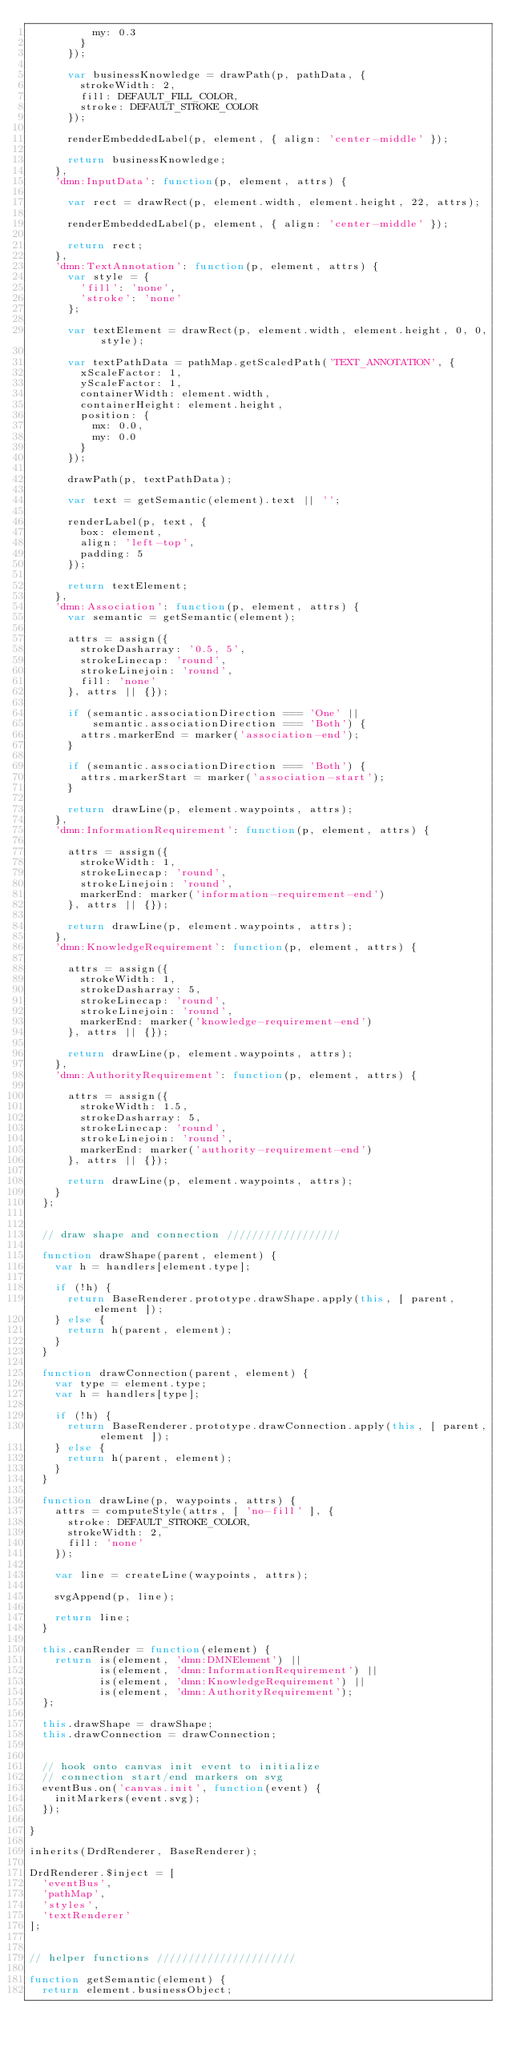Convert code to text. <code><loc_0><loc_0><loc_500><loc_500><_JavaScript_>          my: 0.3
        }
      });

      var businessKnowledge = drawPath(p, pathData, {
        strokeWidth: 2,
        fill: DEFAULT_FILL_COLOR,
        stroke: DEFAULT_STROKE_COLOR
      });

      renderEmbeddedLabel(p, element, { align: 'center-middle' });

      return businessKnowledge;
    },
    'dmn:InputData': function(p, element, attrs) {

      var rect = drawRect(p, element.width, element.height, 22, attrs);

      renderEmbeddedLabel(p, element, { align: 'center-middle' });

      return rect;
    },
    'dmn:TextAnnotation': function(p, element, attrs) {
      var style = {
        'fill': 'none',
        'stroke': 'none'
      };

      var textElement = drawRect(p, element.width, element.height, 0, 0, style);

      var textPathData = pathMap.getScaledPath('TEXT_ANNOTATION', {
        xScaleFactor: 1,
        yScaleFactor: 1,
        containerWidth: element.width,
        containerHeight: element.height,
        position: {
          mx: 0.0,
          my: 0.0
        }
      });

      drawPath(p, textPathData);

      var text = getSemantic(element).text || '';

      renderLabel(p, text, {
        box: element,
        align: 'left-top',
        padding: 5
      });

      return textElement;
    },
    'dmn:Association': function(p, element, attrs) {
      var semantic = getSemantic(element);

      attrs = assign({
        strokeDasharray: '0.5, 5',
        strokeLinecap: 'round',
        strokeLinejoin: 'round',
        fill: 'none'
      }, attrs || {});

      if (semantic.associationDirection === 'One' ||
          semantic.associationDirection === 'Both') {
        attrs.markerEnd = marker('association-end');
      }

      if (semantic.associationDirection === 'Both') {
        attrs.markerStart = marker('association-start');
      }

      return drawLine(p, element.waypoints, attrs);
    },
    'dmn:InformationRequirement': function(p, element, attrs) {

      attrs = assign({
        strokeWidth: 1,
        strokeLinecap: 'round',
        strokeLinejoin: 'round',
        markerEnd: marker('information-requirement-end')
      }, attrs || {});

      return drawLine(p, element.waypoints, attrs);
    },
    'dmn:KnowledgeRequirement': function(p, element, attrs) {

      attrs = assign({
        strokeWidth: 1,
        strokeDasharray: 5,
        strokeLinecap: 'round',
        strokeLinejoin: 'round',
        markerEnd: marker('knowledge-requirement-end')
      }, attrs || {});

      return drawLine(p, element.waypoints, attrs);
    },
    'dmn:AuthorityRequirement': function(p, element, attrs) {

      attrs = assign({
        strokeWidth: 1.5,
        strokeDasharray: 5,
        strokeLinecap: 'round',
        strokeLinejoin: 'round',
        markerEnd: marker('authority-requirement-end')
      }, attrs || {});

      return drawLine(p, element.waypoints, attrs);
    }
  };


  // draw shape and connection //////////////////

  function drawShape(parent, element) {
    var h = handlers[element.type];

    if (!h) {
      return BaseRenderer.prototype.drawShape.apply(this, [ parent, element ]);
    } else {
      return h(parent, element);
    }
  }

  function drawConnection(parent, element) {
    var type = element.type;
    var h = handlers[type];

    if (!h) {
      return BaseRenderer.prototype.drawConnection.apply(this, [ parent, element ]);
    } else {
      return h(parent, element);
    }
  }

  function drawLine(p, waypoints, attrs) {
    attrs = computeStyle(attrs, [ 'no-fill' ], {
      stroke: DEFAULT_STROKE_COLOR,
      strokeWidth: 2,
      fill: 'none'
    });

    var line = createLine(waypoints, attrs);

    svgAppend(p, line);

    return line;
  }

  this.canRender = function(element) {
    return is(element, 'dmn:DMNElement') ||
           is(element, 'dmn:InformationRequirement') ||
           is(element, 'dmn:KnowledgeRequirement') ||
           is(element, 'dmn:AuthorityRequirement');
  };

  this.drawShape = drawShape;
  this.drawConnection = drawConnection;


  // hook onto canvas init event to initialize
  // connection start/end markers on svg
  eventBus.on('canvas.init', function(event) {
    initMarkers(event.svg);
  });

}

inherits(DrdRenderer, BaseRenderer);

DrdRenderer.$inject = [
  'eventBus',
  'pathMap',
  'styles',
  'textRenderer'
];


// helper functions //////////////////////

function getSemantic(element) {
  return element.businessObject;</code> 